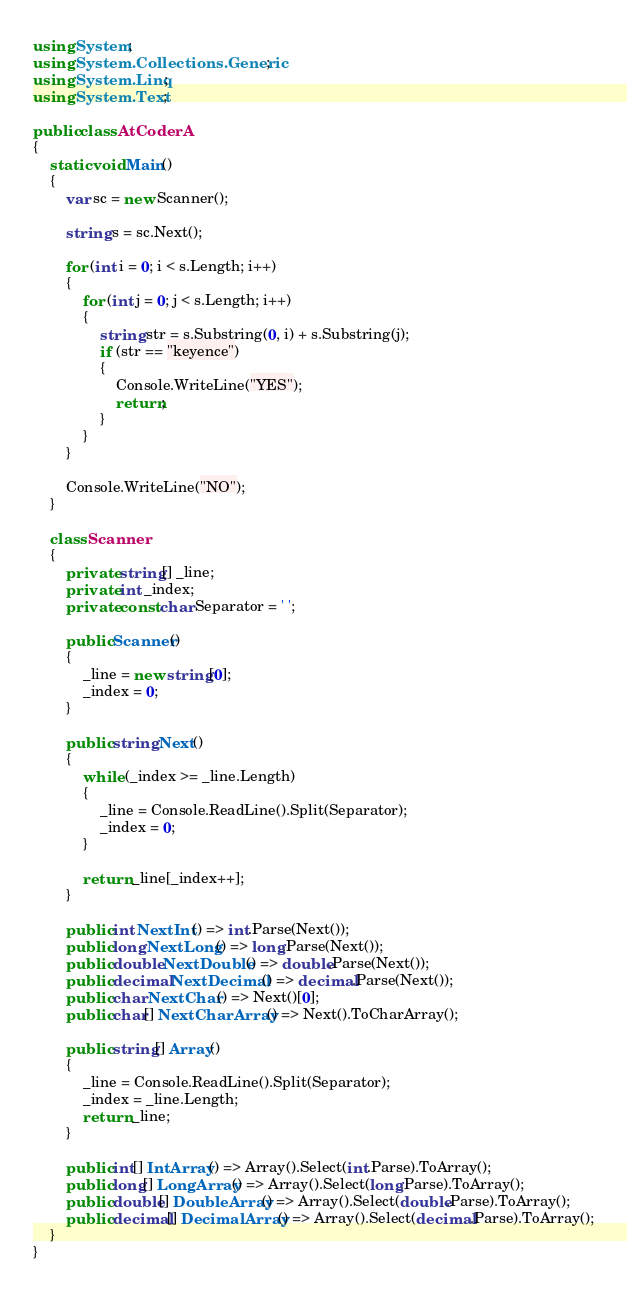<code> <loc_0><loc_0><loc_500><loc_500><_C#_>using System;
using System.Collections.Generic;
using System.Linq;
using System.Text;

public class AtCoderA
{
    static void Main()
    {
        var sc = new Scanner();

        string s = sc.Next();

        for (int i = 0; i < s.Length; i++)
        {
            for (int j = 0; j < s.Length; i++)
            {
                string str = s.Substring(0, i) + s.Substring(j);
                if (str == "keyence")
                {
                    Console.WriteLine("YES");
                    return;
                }
            }
        }

        Console.WriteLine("NO");
    }

    class Scanner
    {
        private string[] _line;
        private int _index;
        private const char Separator = ' ';

        public Scanner()
        {
            _line = new string[0];
            _index = 0;
        }

        public string Next()
        {
            while (_index >= _line.Length)
            {
                _line = Console.ReadLine().Split(Separator);
                _index = 0;
            }

            return _line[_index++];
        }

        public int NextInt() => int.Parse(Next());
        public long NextLong() => long.Parse(Next());
        public double NextDouble() => double.Parse(Next());
        public decimal NextDecimal() => decimal.Parse(Next());
        public char NextChar() => Next()[0];
        public char[] NextCharArray() => Next().ToCharArray();

        public string[] Array()
        {
            _line = Console.ReadLine().Split(Separator);
            _index = _line.Length;
            return _line;
        }

        public int[] IntArray() => Array().Select(int.Parse).ToArray();
        public long[] LongArray() => Array().Select(long.Parse).ToArray();
        public double[] DoubleArray() => Array().Select(double.Parse).ToArray();
        public decimal[] DecimalArray() => Array().Select(decimal.Parse).ToArray();
    }
}
</code> 